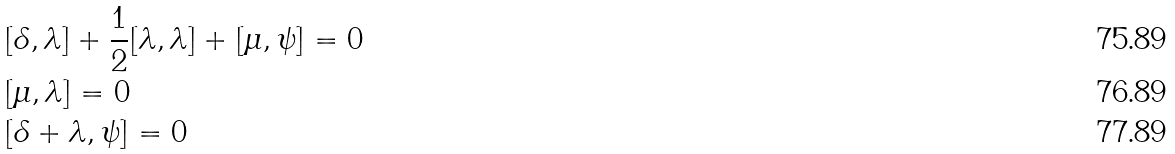<formula> <loc_0><loc_0><loc_500><loc_500>& [ \delta , \lambda ] + \frac { 1 } { 2 } [ \lambda , \lambda ] + [ \mu , \psi ] = 0 \\ & [ \mu , \lambda ] = 0 \\ & [ \delta + \lambda , \psi ] = 0</formula> 